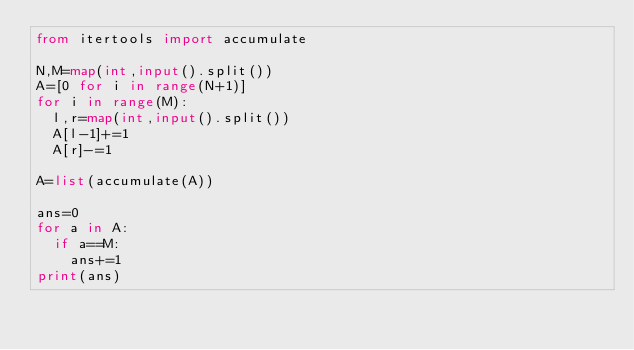<code> <loc_0><loc_0><loc_500><loc_500><_Python_>from itertools import accumulate

N,M=map(int,input().split())
A=[0 for i in range(N+1)]
for i in range(M):
  l,r=map(int,input().split())
  A[l-1]+=1
  A[r]-=1

A=list(accumulate(A))

ans=0
for a in A:
  if a==M:
    ans+=1
print(ans)</code> 